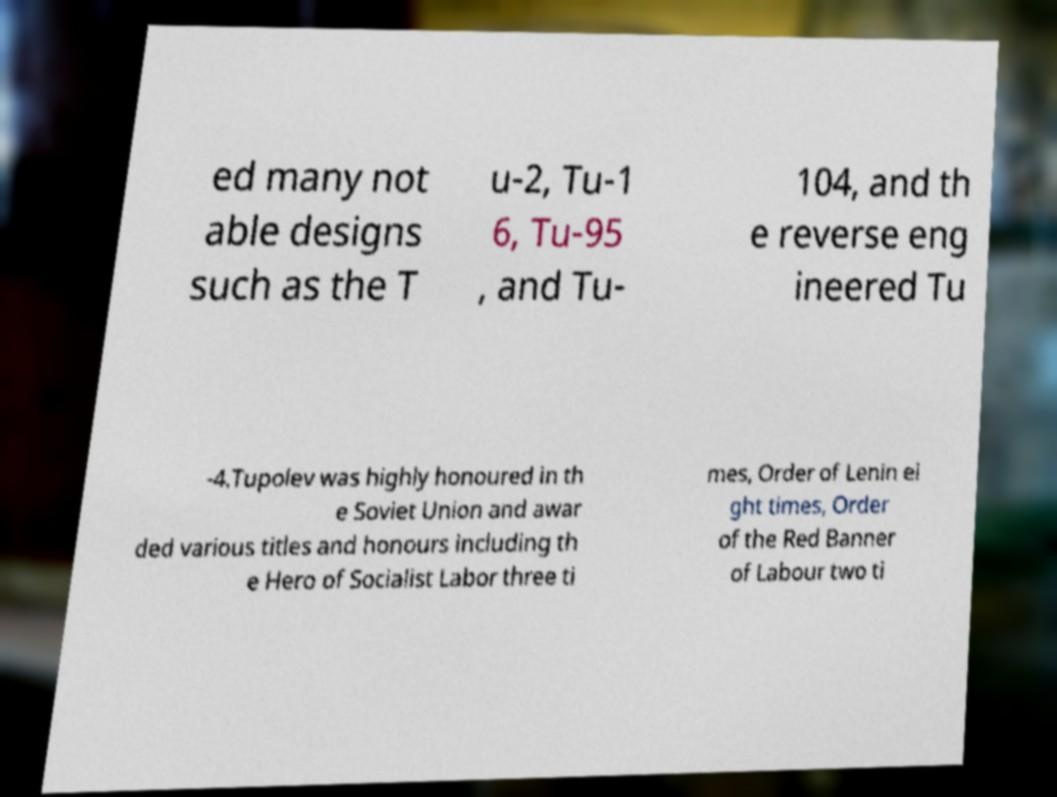For documentation purposes, I need the text within this image transcribed. Could you provide that? ed many not able designs such as the T u-2, Tu-1 6, Tu-95 , and Tu- 104, and th e reverse eng ineered Tu -4.Tupolev was highly honoured in th e Soviet Union and awar ded various titles and honours including th e Hero of Socialist Labor three ti mes, Order of Lenin ei ght times, Order of the Red Banner of Labour two ti 